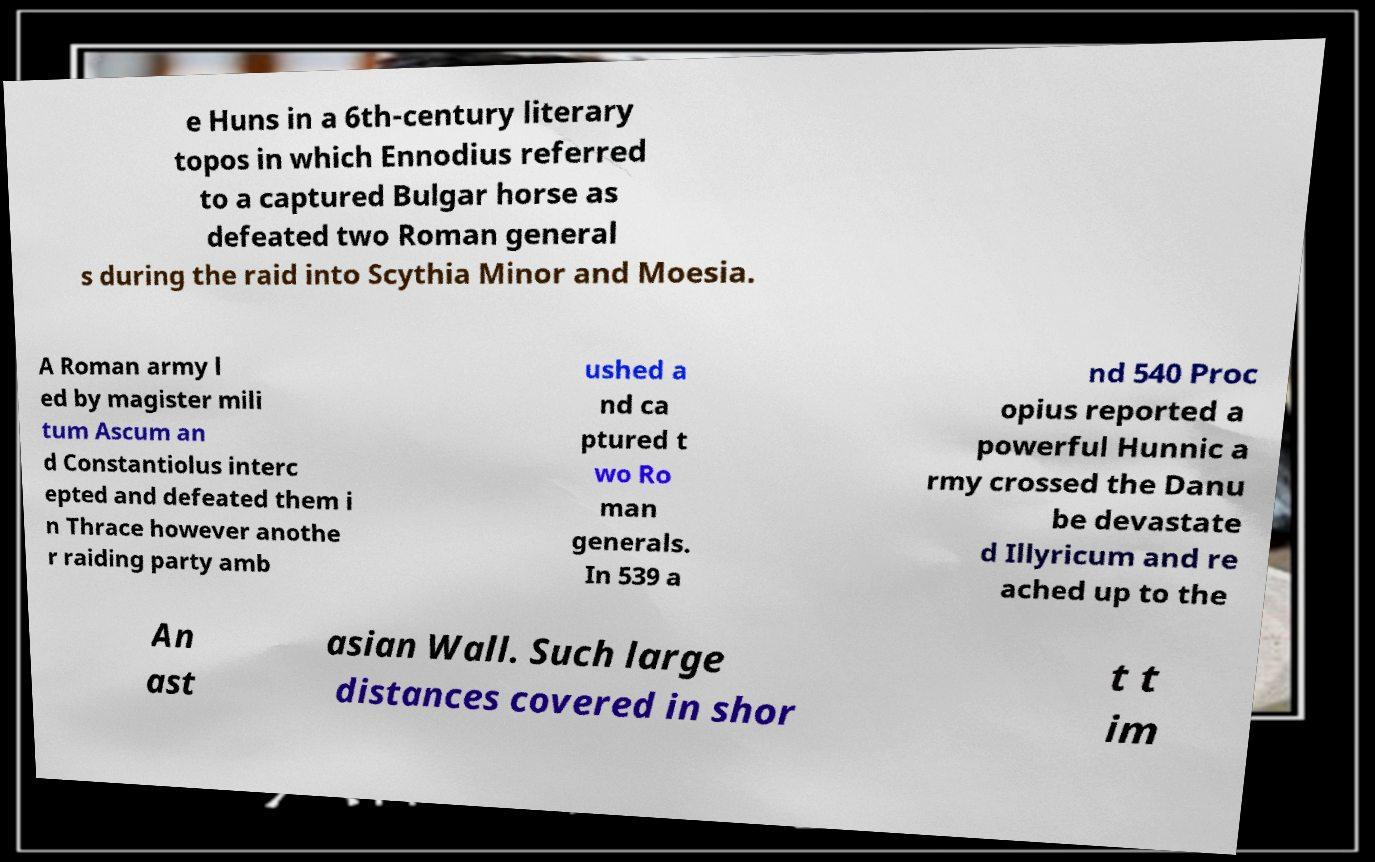Can you read and provide the text displayed in the image?This photo seems to have some interesting text. Can you extract and type it out for me? e Huns in a 6th-century literary topos in which Ennodius referred to a captured Bulgar horse as defeated two Roman general s during the raid into Scythia Minor and Moesia. A Roman army l ed by magister mili tum Ascum an d Constantiolus interc epted and defeated them i n Thrace however anothe r raiding party amb ushed a nd ca ptured t wo Ro man generals. In 539 a nd 540 Proc opius reported a powerful Hunnic a rmy crossed the Danu be devastate d Illyricum and re ached up to the An ast asian Wall. Such large distances covered in shor t t im 